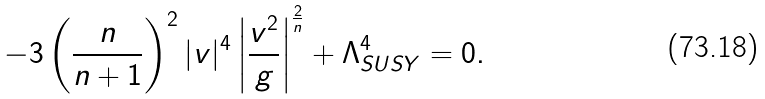<formula> <loc_0><loc_0><loc_500><loc_500>- 3 \left ( \frac { n } { n + 1 } \right ) ^ { 2 } | v | ^ { 4 } \left | \frac { v ^ { 2 } } { g } \right | ^ { \frac { 2 } { n } } + \Lambda ^ { 4 } _ { S U S Y } = 0 .</formula> 